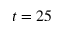<formula> <loc_0><loc_0><loc_500><loc_500>t = 2 5</formula> 